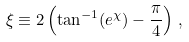Convert formula to latex. <formula><loc_0><loc_0><loc_500><loc_500>\xi \equiv 2 \left ( \tan ^ { - 1 } ( e ^ { \chi } ) - { \frac { \pi } { 4 } } \right ) \, ,</formula> 